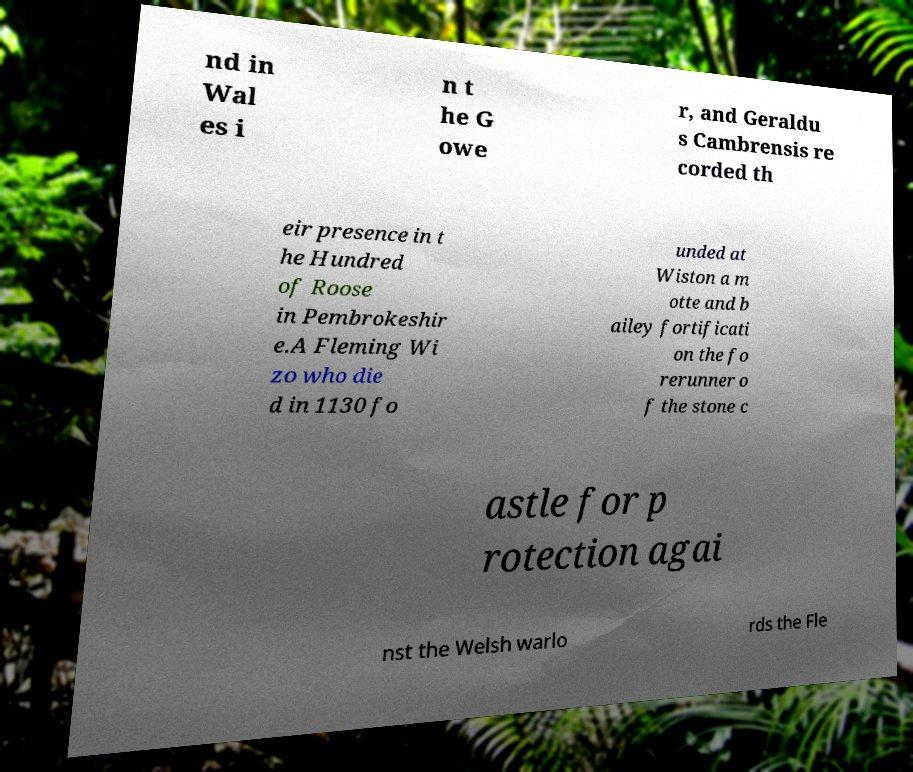What messages or text are displayed in this image? I need them in a readable, typed format. nd in Wal es i n t he G owe r, and Geraldu s Cambrensis re corded th eir presence in t he Hundred of Roose in Pembrokeshir e.A Fleming Wi zo who die d in 1130 fo unded at Wiston a m otte and b ailey fortificati on the fo rerunner o f the stone c astle for p rotection agai nst the Welsh warlo rds the Fle 